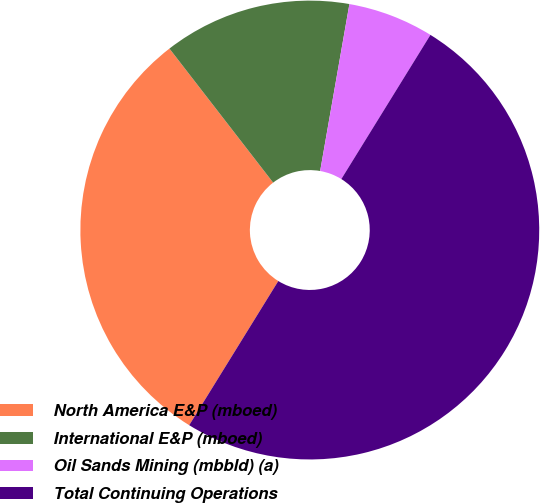<chart> <loc_0><loc_0><loc_500><loc_500><pie_chart><fcel>North America E&P (mboed)<fcel>International E&P (mboed)<fcel>Oil Sands Mining (mbbld) (a)<fcel>Total Continuing Operations<nl><fcel>30.71%<fcel>13.24%<fcel>6.05%<fcel>50.0%<nl></chart> 